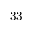Convert formula to latex. <formula><loc_0><loc_0><loc_500><loc_500>3 3</formula> 